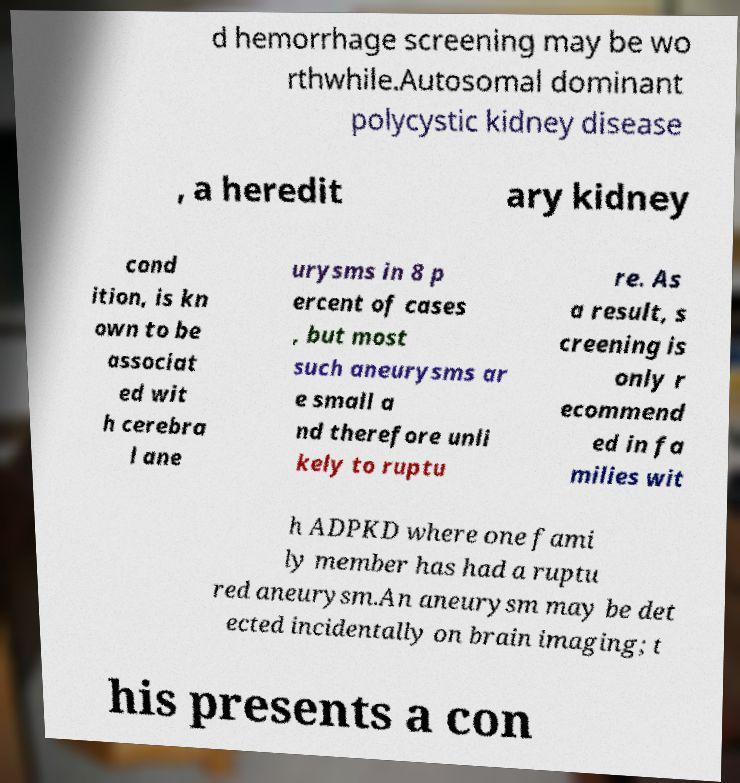Can you accurately transcribe the text from the provided image for me? d hemorrhage screening may be wo rthwhile.Autosomal dominant polycystic kidney disease , a heredit ary kidney cond ition, is kn own to be associat ed wit h cerebra l ane urysms in 8 p ercent of cases , but most such aneurysms ar e small a nd therefore unli kely to ruptu re. As a result, s creening is only r ecommend ed in fa milies wit h ADPKD where one fami ly member has had a ruptu red aneurysm.An aneurysm may be det ected incidentally on brain imaging; t his presents a con 